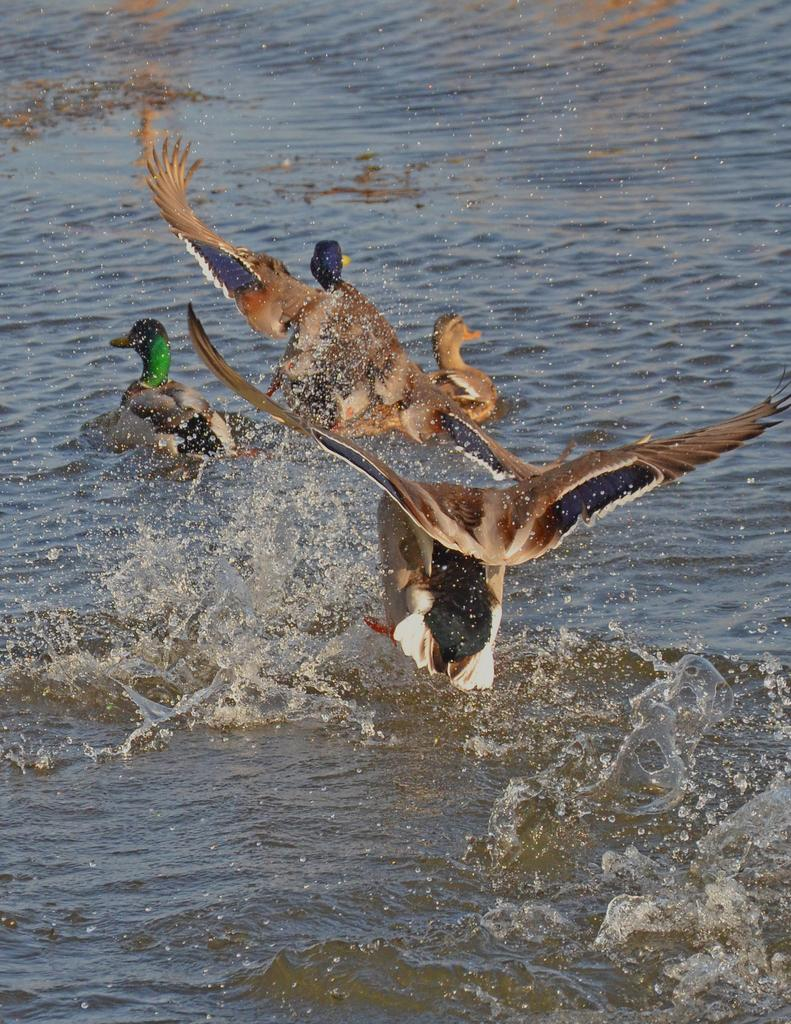What is happening with the birds in the image? There are two birds flying in the image. Can you describe the background of the image? In the background of the image, there are birds in the water. What type of locket can be seen hanging from the neck of one of the birds in the image? There is no locket present on any of the birds in the image. What force is causing the birds to fly in the image? The birds are flying under their own power, and there is no external force causing them to fly in the image. 